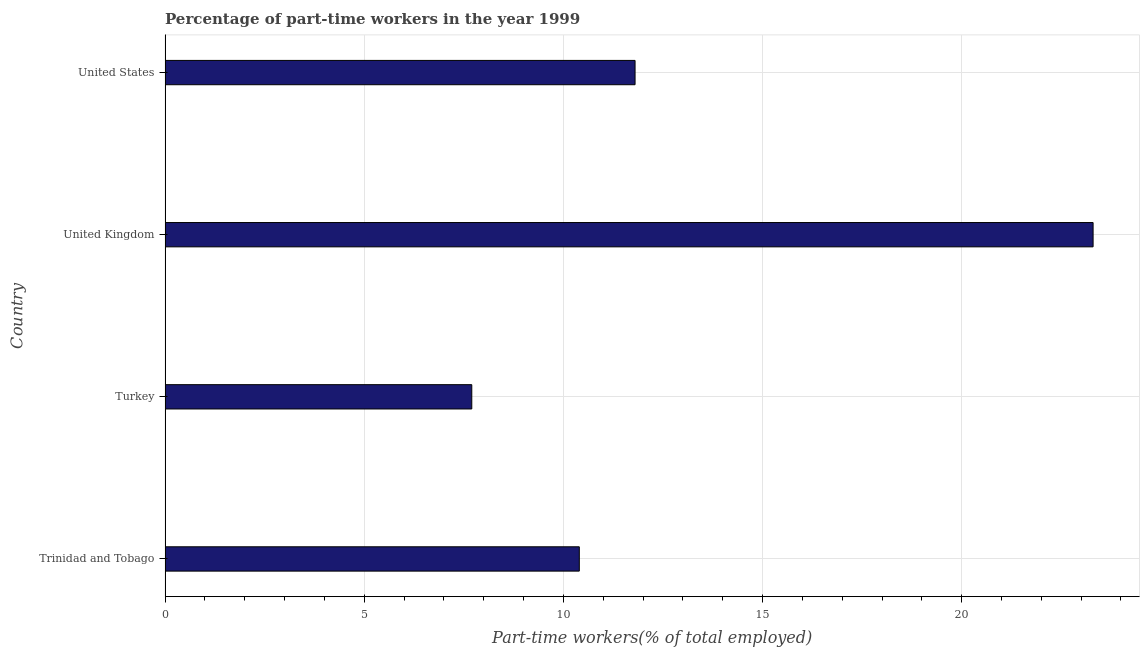What is the title of the graph?
Offer a terse response. Percentage of part-time workers in the year 1999. What is the label or title of the X-axis?
Provide a short and direct response. Part-time workers(% of total employed). What is the label or title of the Y-axis?
Your answer should be very brief. Country. What is the percentage of part-time workers in United Kingdom?
Ensure brevity in your answer.  23.3. Across all countries, what is the maximum percentage of part-time workers?
Make the answer very short. 23.3. Across all countries, what is the minimum percentage of part-time workers?
Ensure brevity in your answer.  7.7. In which country was the percentage of part-time workers minimum?
Keep it short and to the point. Turkey. What is the sum of the percentage of part-time workers?
Offer a very short reply. 53.2. What is the average percentage of part-time workers per country?
Offer a very short reply. 13.3. What is the median percentage of part-time workers?
Keep it short and to the point. 11.1. In how many countries, is the percentage of part-time workers greater than 3 %?
Provide a short and direct response. 4. What is the ratio of the percentage of part-time workers in Turkey to that in United States?
Make the answer very short. 0.65. What is the difference between the highest and the second highest percentage of part-time workers?
Provide a succinct answer. 11.5. What is the difference between the highest and the lowest percentage of part-time workers?
Your answer should be very brief. 15.6. In how many countries, is the percentage of part-time workers greater than the average percentage of part-time workers taken over all countries?
Offer a very short reply. 1. How many countries are there in the graph?
Provide a succinct answer. 4. What is the difference between two consecutive major ticks on the X-axis?
Make the answer very short. 5. Are the values on the major ticks of X-axis written in scientific E-notation?
Provide a succinct answer. No. What is the Part-time workers(% of total employed) of Trinidad and Tobago?
Offer a very short reply. 10.4. What is the Part-time workers(% of total employed) of Turkey?
Your answer should be very brief. 7.7. What is the Part-time workers(% of total employed) in United Kingdom?
Make the answer very short. 23.3. What is the Part-time workers(% of total employed) of United States?
Give a very brief answer. 11.8. What is the difference between the Part-time workers(% of total employed) in Turkey and United Kingdom?
Give a very brief answer. -15.6. What is the difference between the Part-time workers(% of total employed) in United Kingdom and United States?
Keep it short and to the point. 11.5. What is the ratio of the Part-time workers(% of total employed) in Trinidad and Tobago to that in Turkey?
Offer a very short reply. 1.35. What is the ratio of the Part-time workers(% of total employed) in Trinidad and Tobago to that in United Kingdom?
Offer a very short reply. 0.45. What is the ratio of the Part-time workers(% of total employed) in Trinidad and Tobago to that in United States?
Give a very brief answer. 0.88. What is the ratio of the Part-time workers(% of total employed) in Turkey to that in United Kingdom?
Give a very brief answer. 0.33. What is the ratio of the Part-time workers(% of total employed) in Turkey to that in United States?
Give a very brief answer. 0.65. What is the ratio of the Part-time workers(% of total employed) in United Kingdom to that in United States?
Give a very brief answer. 1.98. 